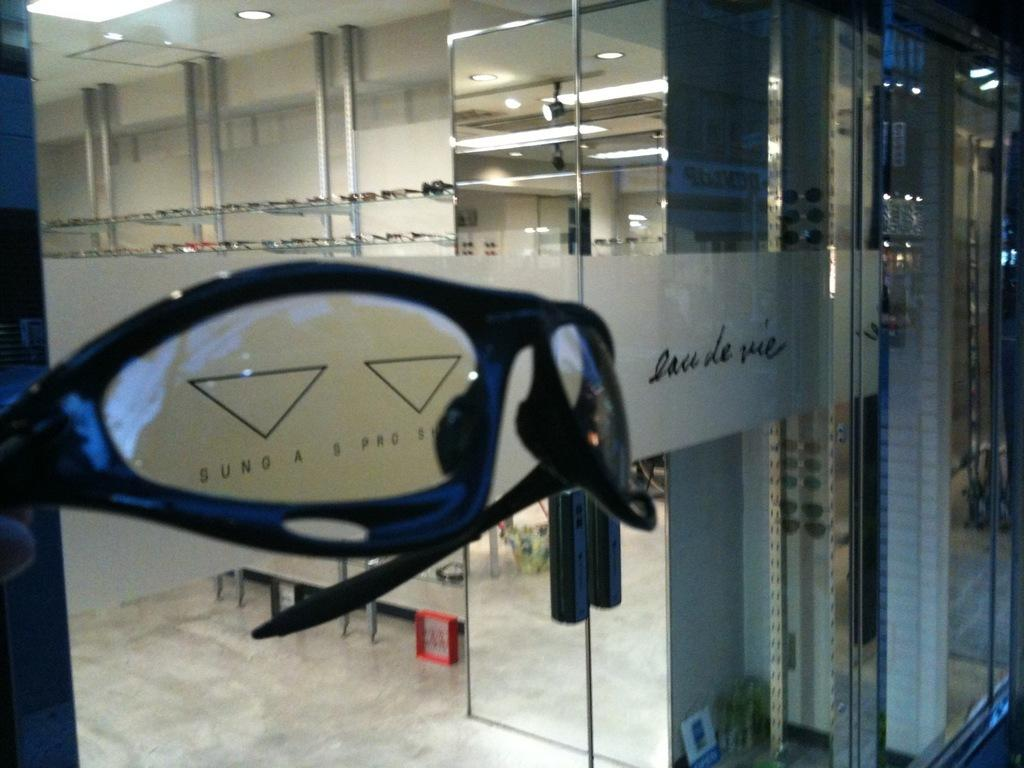What type of door is visible in the image? There is a glass door in the image. What can be seen on the ceiling in the background of the image? There are lights on the ceiling in the background of the image. What else is visible on the floor in the image? There are other objects visible on the floor in the image. How many cubs are playing with the thing on the floor in the image? There are no cubs or things present in the image. 